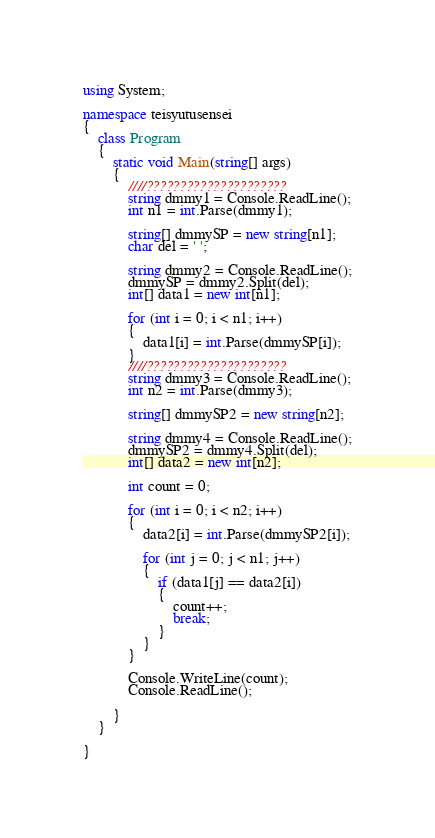Convert code to text. <code><loc_0><loc_0><loc_500><loc_500><_C#_>using System;

namespace teisyutusensei
{
    class Program
    {
        static void Main(string[] args)
        {
            ////?????????????????????
            string dmmy1 = Console.ReadLine();
            int n1 = int.Parse(dmmy1);
 
            string[] dmmySP = new string[n1];
            char del = ' ';

            string dmmy2 = Console.ReadLine();
            dmmySP = dmmy2.Split(del);
            int[] data1 = new int[n1];

            for (int i = 0; i < n1; i++)
            {
                data1[i] = int.Parse(dmmySP[i]);
            }
            ////?????????????????????
            string dmmy3 = Console.ReadLine();
            int n2 = int.Parse(dmmy3);

            string[] dmmySP2 = new string[n2];

            string dmmy4 = Console.ReadLine();
            dmmySP2 = dmmy4.Split(del);
            int[] data2 = new int[n2];

            int count = 0;

            for (int i = 0; i < n2; i++)
            {
                data2[i] = int.Parse(dmmySP2[i]);

                for (int j = 0; j < n1; j++)
                {
                    if (data1[j] == data2[i])
                    {
                        count++;
                        break;
                    }
                }
            }

            Console.WriteLine(count);
            Console.ReadLine();

        }
    }

}</code> 